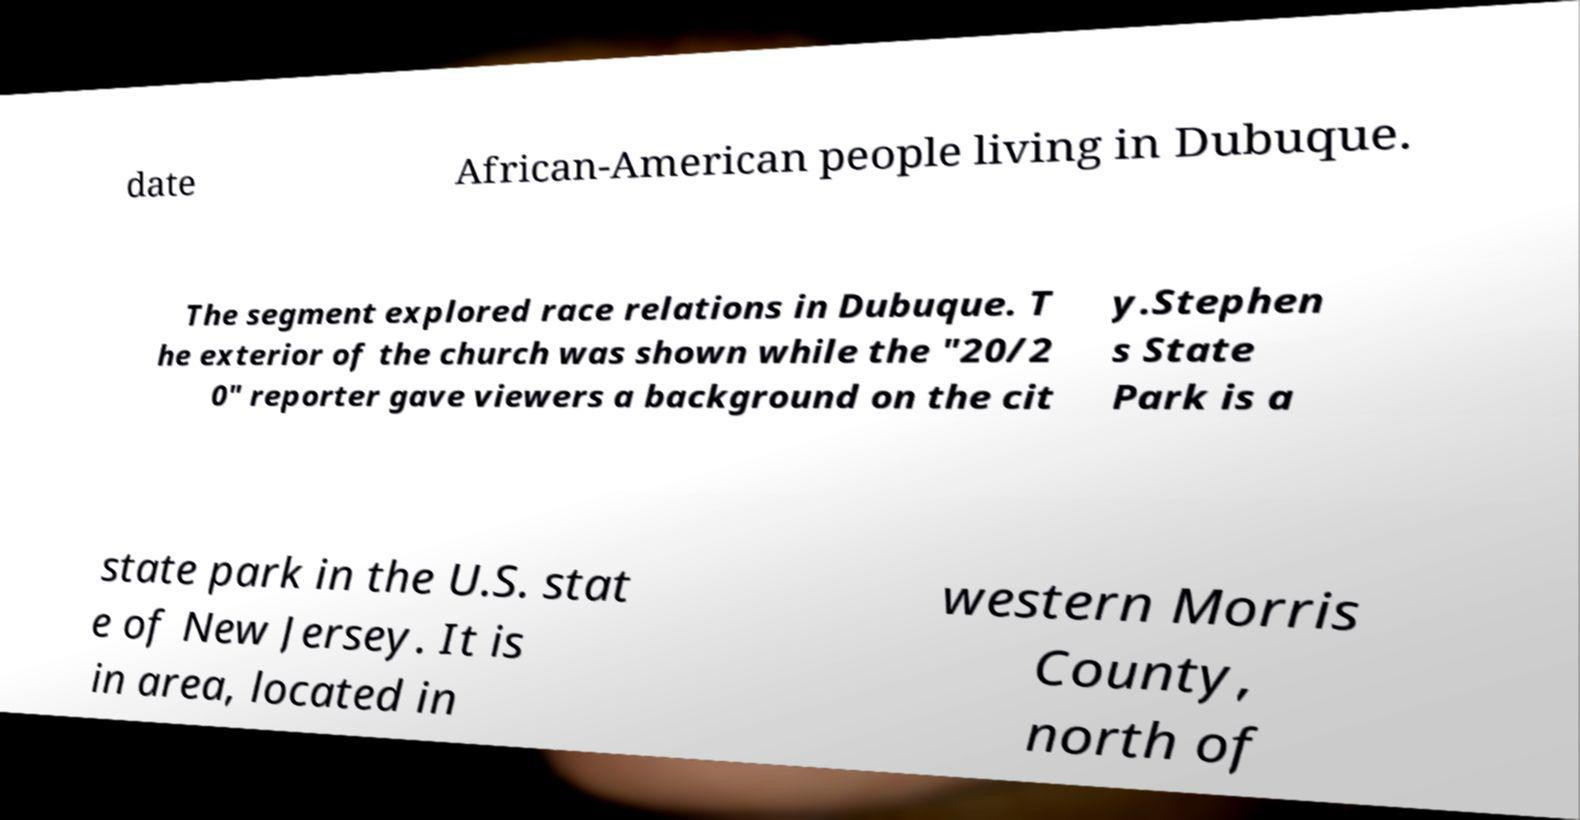There's text embedded in this image that I need extracted. Can you transcribe it verbatim? date African-American people living in Dubuque. The segment explored race relations in Dubuque. T he exterior of the church was shown while the "20/2 0" reporter gave viewers a background on the cit y.Stephen s State Park is a state park in the U.S. stat e of New Jersey. It is in area, located in western Morris County, north of 